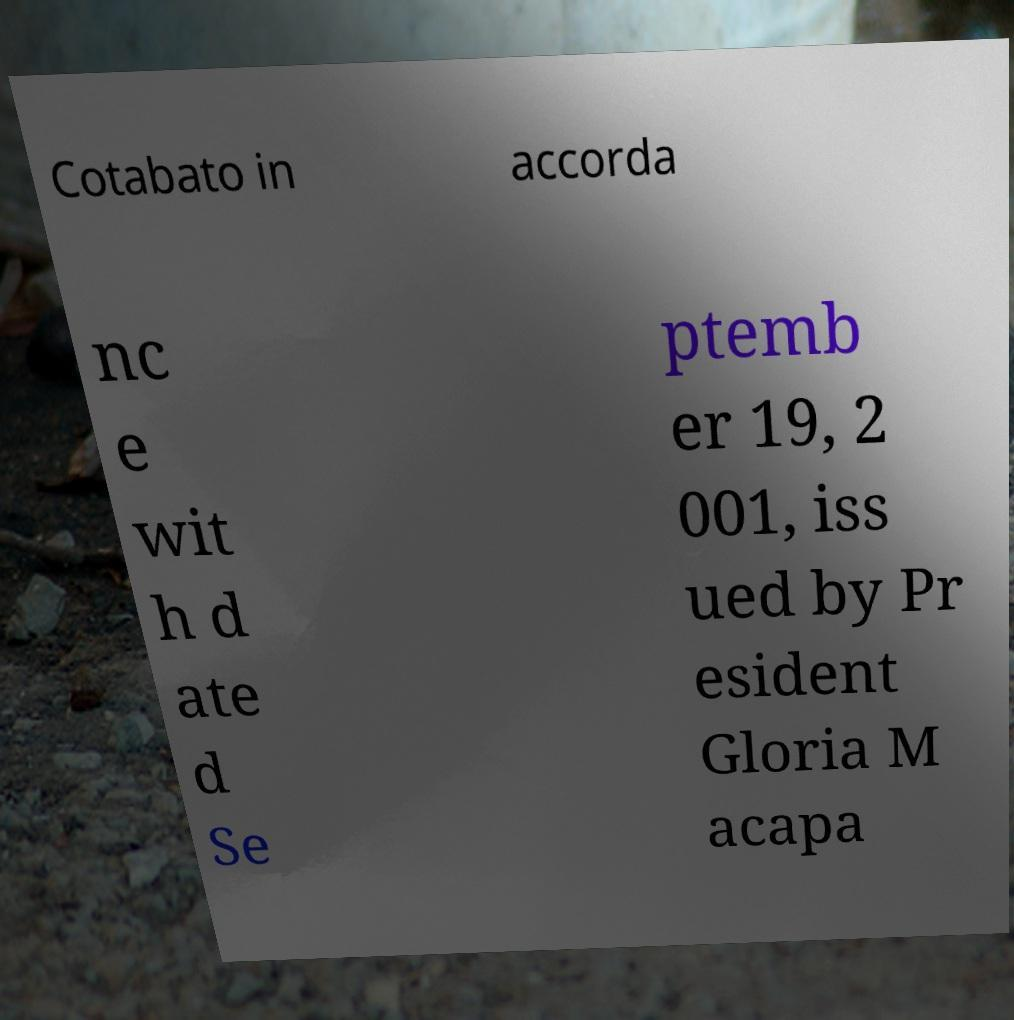Could you assist in decoding the text presented in this image and type it out clearly? Cotabato in accorda nc e wit h d ate d Se ptemb er 19, 2 001, iss ued by Pr esident Gloria M acapa 